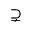<formula> <loc_0><loc_0><loc_500><loc_500>\supsetneq</formula> 